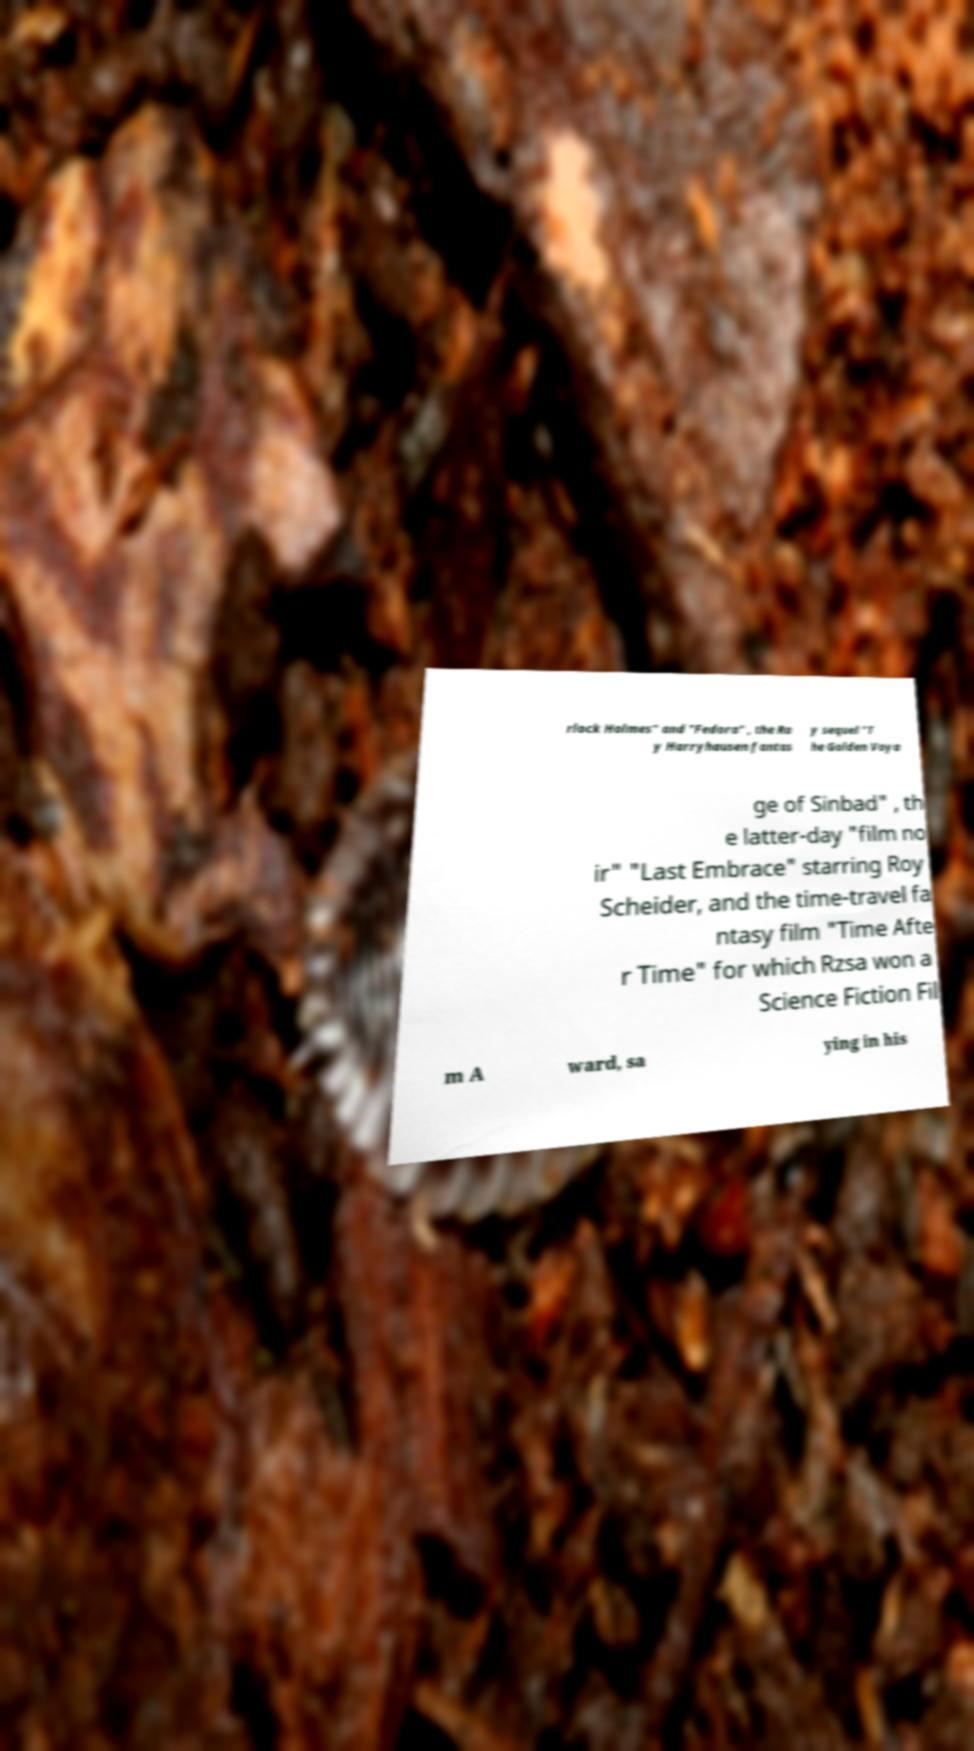Can you read and provide the text displayed in the image?This photo seems to have some interesting text. Can you extract and type it out for me? rlock Holmes" and "Fedora" , the Ra y Harryhausen fantas y sequel "T he Golden Voya ge of Sinbad" , th e latter-day "film no ir" "Last Embrace" starring Roy Scheider, and the time-travel fa ntasy film "Time Afte r Time" for which Rzsa won a Science Fiction Fil m A ward, sa ying in his 